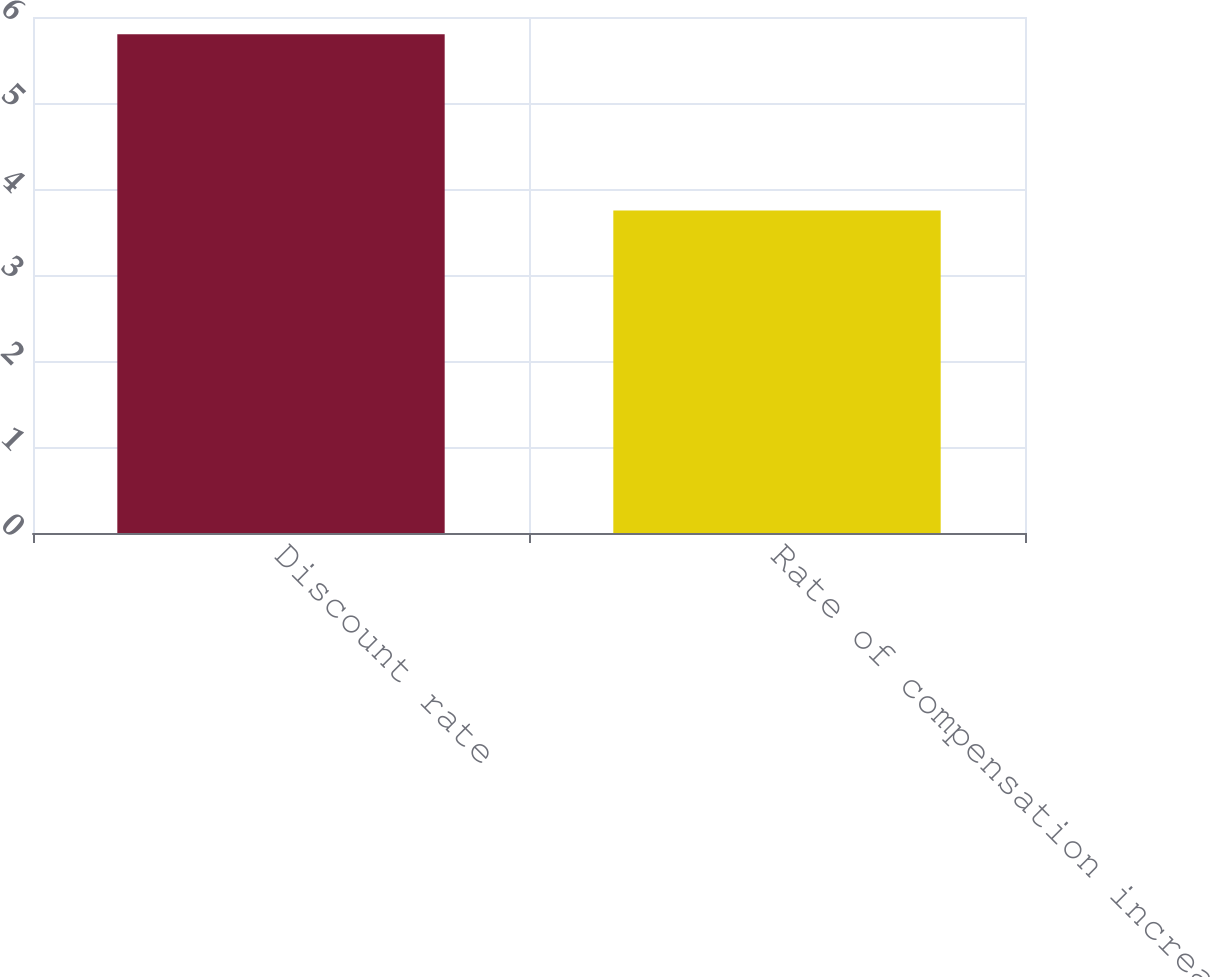Convert chart. <chart><loc_0><loc_0><loc_500><loc_500><bar_chart><fcel>Discount rate<fcel>Rate of compensation increase<nl><fcel>5.8<fcel>3.75<nl></chart> 